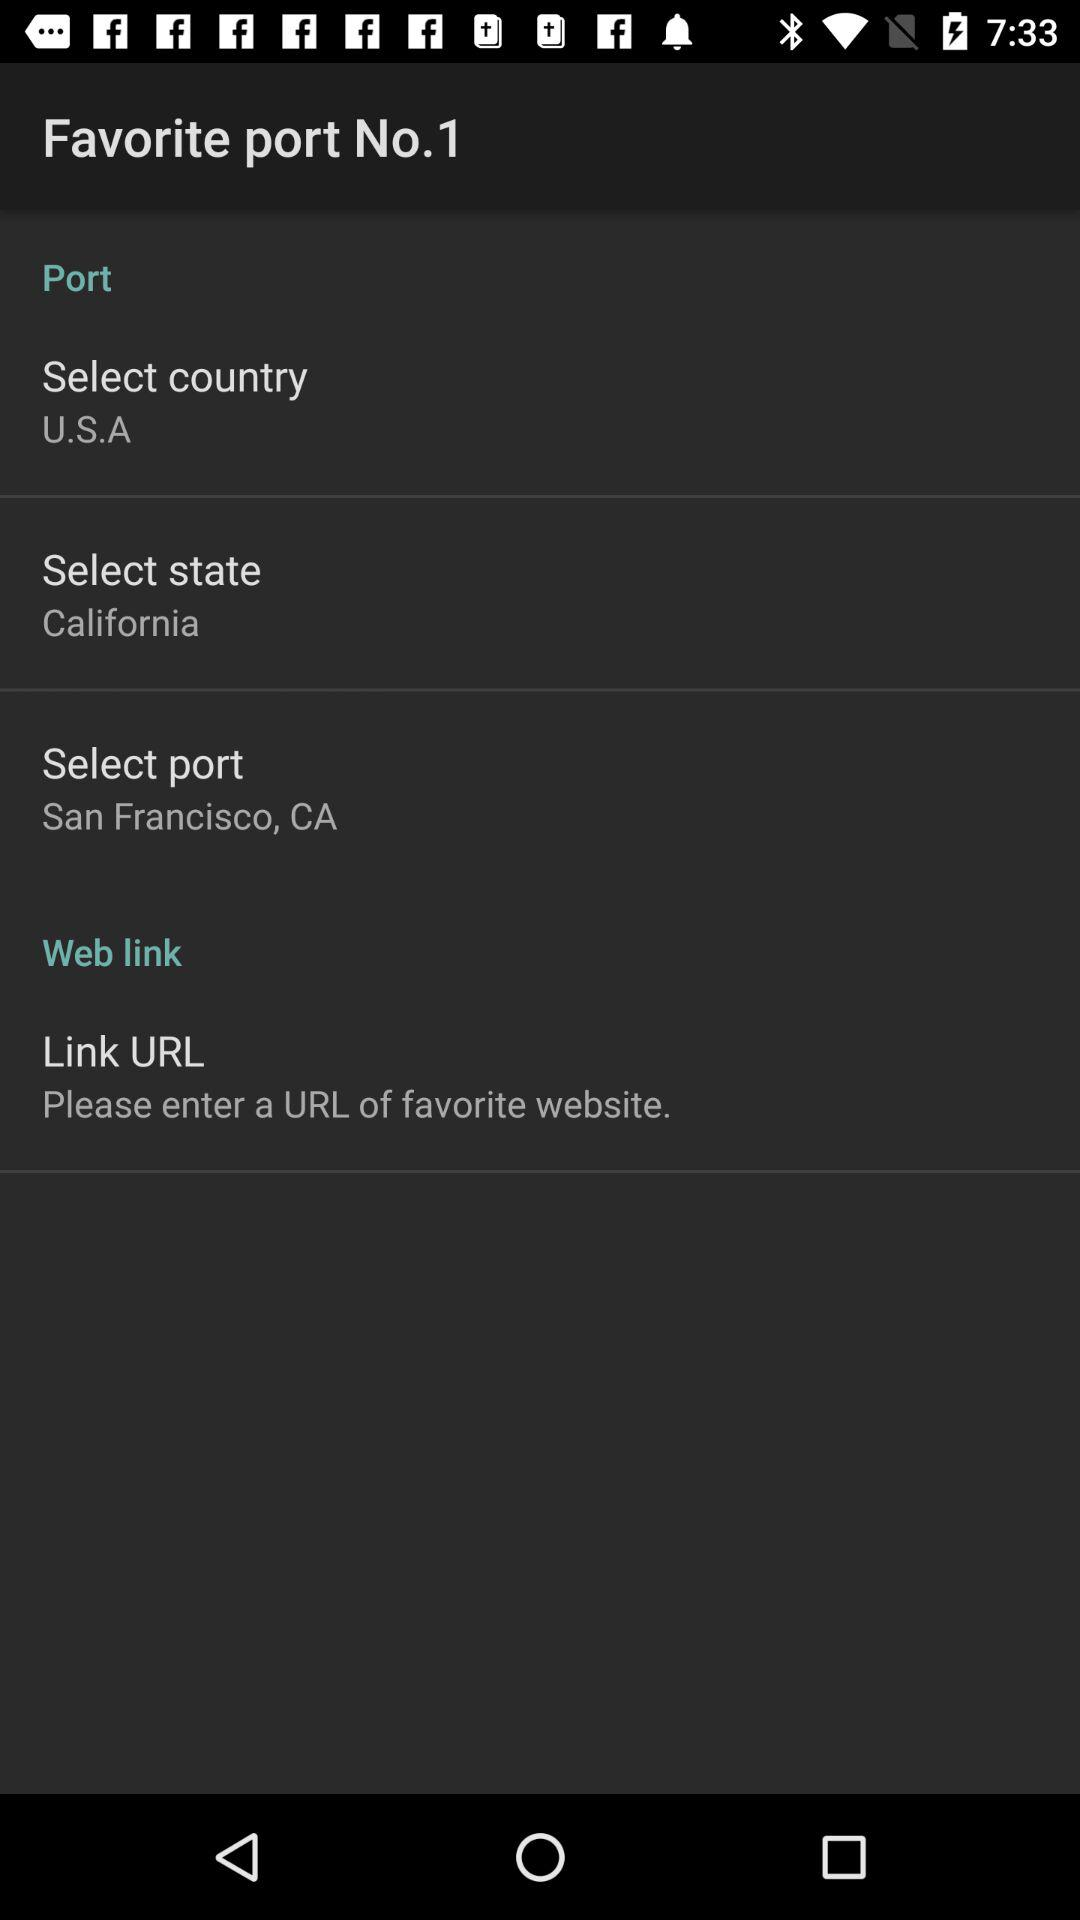What is the number of the port? The port number is 1. 